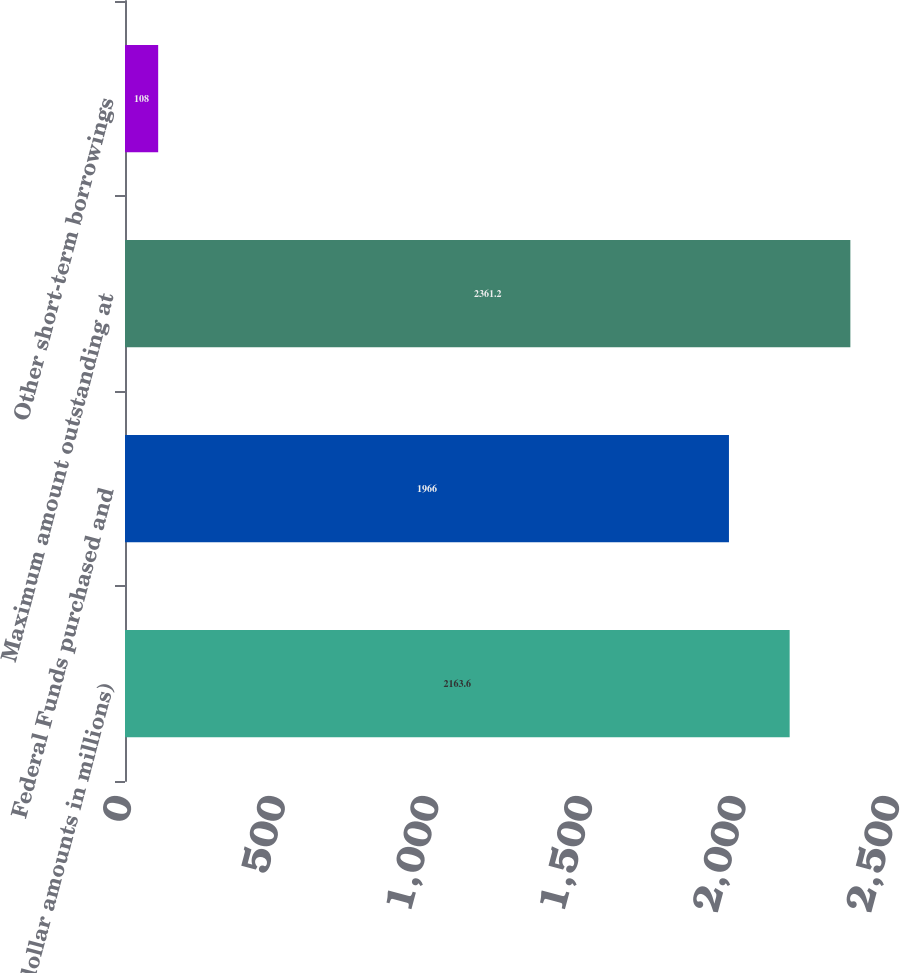Convert chart to OTSL. <chart><loc_0><loc_0><loc_500><loc_500><bar_chart><fcel>(dollar amounts in millions)<fcel>Federal Funds purchased and<fcel>Maximum amount outstanding at<fcel>Other short-term borrowings<nl><fcel>2163.6<fcel>1966<fcel>2361.2<fcel>108<nl></chart> 